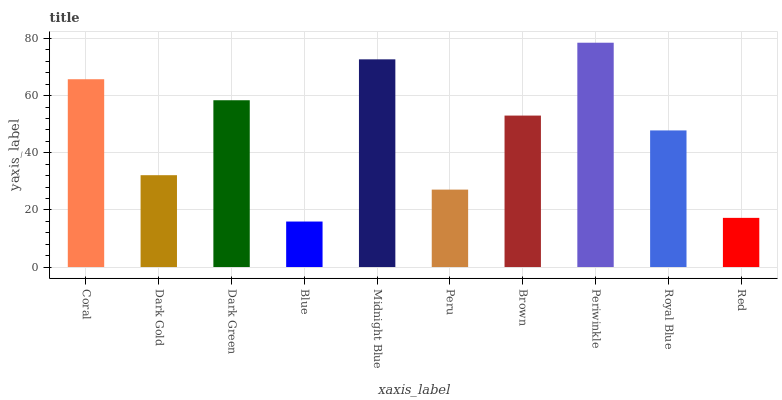Is Blue the minimum?
Answer yes or no. Yes. Is Periwinkle the maximum?
Answer yes or no. Yes. Is Dark Gold the minimum?
Answer yes or no. No. Is Dark Gold the maximum?
Answer yes or no. No. Is Coral greater than Dark Gold?
Answer yes or no. Yes. Is Dark Gold less than Coral?
Answer yes or no. Yes. Is Dark Gold greater than Coral?
Answer yes or no. No. Is Coral less than Dark Gold?
Answer yes or no. No. Is Brown the high median?
Answer yes or no. Yes. Is Royal Blue the low median?
Answer yes or no. Yes. Is Midnight Blue the high median?
Answer yes or no. No. Is Red the low median?
Answer yes or no. No. 